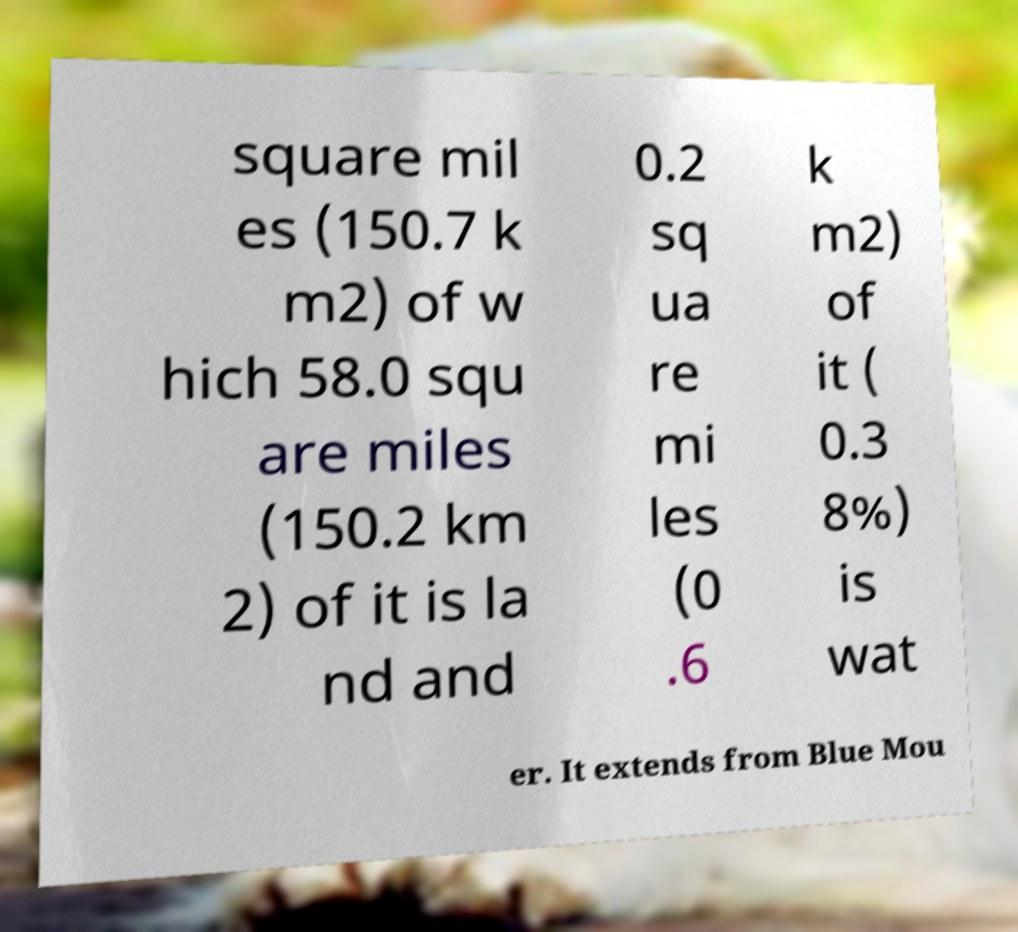Please identify and transcribe the text found in this image. square mil es (150.7 k m2) of w hich 58.0 squ are miles (150.2 km 2) of it is la nd and 0.2 sq ua re mi les (0 .6 k m2) of it ( 0.3 8%) is wat er. It extends from Blue Mou 